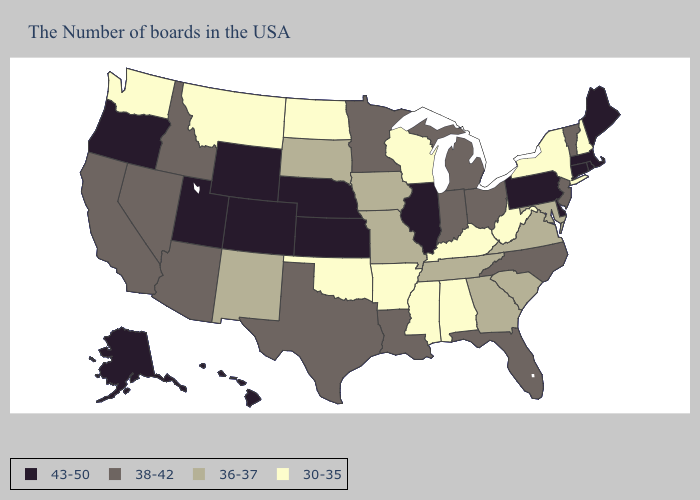Among the states that border South Dakota , does Montana have the lowest value?
Answer briefly. Yes. Among the states that border Indiana , which have the lowest value?
Write a very short answer. Kentucky. Name the states that have a value in the range 30-35?
Give a very brief answer. New Hampshire, New York, West Virginia, Kentucky, Alabama, Wisconsin, Mississippi, Arkansas, Oklahoma, North Dakota, Montana, Washington. Name the states that have a value in the range 43-50?
Write a very short answer. Maine, Massachusetts, Rhode Island, Connecticut, Delaware, Pennsylvania, Illinois, Kansas, Nebraska, Wyoming, Colorado, Utah, Oregon, Alaska, Hawaii. What is the value of Tennessee?
Answer briefly. 36-37. What is the value of Kentucky?
Keep it brief. 30-35. What is the value of Vermont?
Write a very short answer. 38-42. Among the states that border Wisconsin , does Michigan have the lowest value?
Give a very brief answer. No. Is the legend a continuous bar?
Be succinct. No. Which states have the lowest value in the Northeast?
Short answer required. New Hampshire, New York. Does the first symbol in the legend represent the smallest category?
Give a very brief answer. No. Does the first symbol in the legend represent the smallest category?
Keep it brief. No. Which states have the lowest value in the USA?
Answer briefly. New Hampshire, New York, West Virginia, Kentucky, Alabama, Wisconsin, Mississippi, Arkansas, Oklahoma, North Dakota, Montana, Washington. Which states hav the highest value in the MidWest?
Be succinct. Illinois, Kansas, Nebraska. 